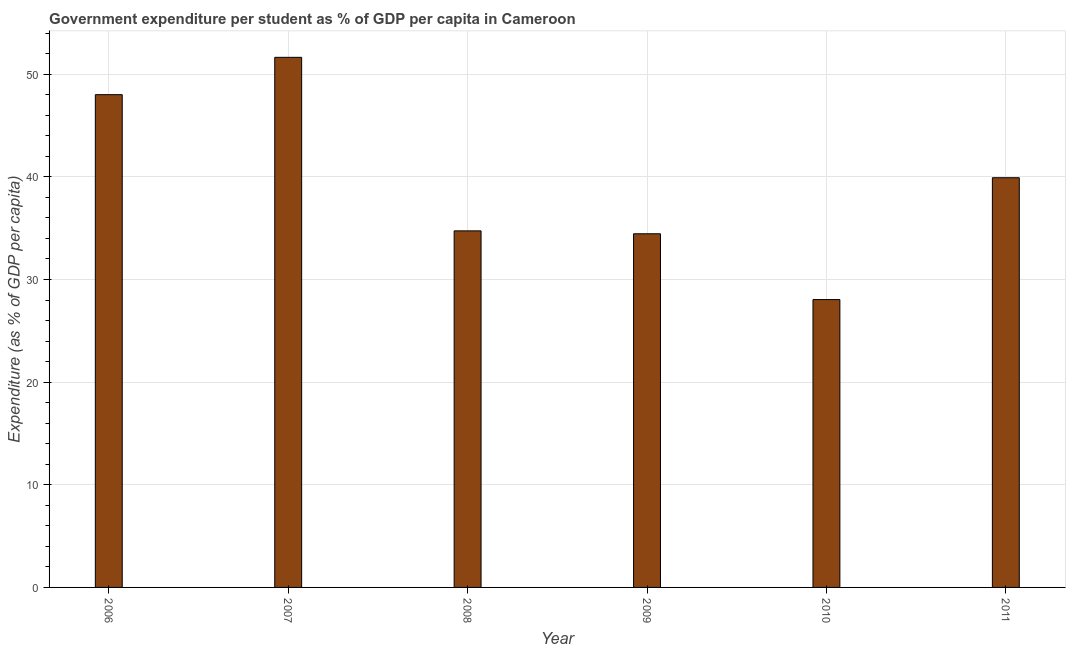Does the graph contain any zero values?
Offer a very short reply. No. What is the title of the graph?
Provide a succinct answer. Government expenditure per student as % of GDP per capita in Cameroon. What is the label or title of the X-axis?
Ensure brevity in your answer.  Year. What is the label or title of the Y-axis?
Your answer should be very brief. Expenditure (as % of GDP per capita). What is the government expenditure per student in 2006?
Ensure brevity in your answer.  48.01. Across all years, what is the maximum government expenditure per student?
Ensure brevity in your answer.  51.64. Across all years, what is the minimum government expenditure per student?
Keep it short and to the point. 28.04. In which year was the government expenditure per student maximum?
Offer a very short reply. 2007. What is the sum of the government expenditure per student?
Your response must be concise. 236.81. What is the difference between the government expenditure per student in 2006 and 2010?
Keep it short and to the point. 19.96. What is the average government expenditure per student per year?
Your answer should be very brief. 39.47. What is the median government expenditure per student?
Provide a short and direct response. 37.33. What is the ratio of the government expenditure per student in 2007 to that in 2010?
Make the answer very short. 1.84. Is the difference between the government expenditure per student in 2009 and 2011 greater than the difference between any two years?
Keep it short and to the point. No. What is the difference between the highest and the second highest government expenditure per student?
Provide a succinct answer. 3.64. What is the difference between the highest and the lowest government expenditure per student?
Make the answer very short. 23.6. How many bars are there?
Offer a very short reply. 6. Are all the bars in the graph horizontal?
Provide a short and direct response. No. How many years are there in the graph?
Offer a terse response. 6. What is the difference between two consecutive major ticks on the Y-axis?
Make the answer very short. 10. What is the Expenditure (as % of GDP per capita) in 2006?
Your response must be concise. 48.01. What is the Expenditure (as % of GDP per capita) in 2007?
Your answer should be compact. 51.64. What is the Expenditure (as % of GDP per capita) of 2008?
Your answer should be compact. 34.74. What is the Expenditure (as % of GDP per capita) of 2009?
Offer a terse response. 34.46. What is the Expenditure (as % of GDP per capita) of 2010?
Ensure brevity in your answer.  28.04. What is the Expenditure (as % of GDP per capita) in 2011?
Give a very brief answer. 39.92. What is the difference between the Expenditure (as % of GDP per capita) in 2006 and 2007?
Ensure brevity in your answer.  -3.64. What is the difference between the Expenditure (as % of GDP per capita) in 2006 and 2008?
Ensure brevity in your answer.  13.27. What is the difference between the Expenditure (as % of GDP per capita) in 2006 and 2009?
Offer a terse response. 13.55. What is the difference between the Expenditure (as % of GDP per capita) in 2006 and 2010?
Your answer should be very brief. 19.96. What is the difference between the Expenditure (as % of GDP per capita) in 2006 and 2011?
Your answer should be very brief. 8.09. What is the difference between the Expenditure (as % of GDP per capita) in 2007 and 2008?
Provide a succinct answer. 16.91. What is the difference between the Expenditure (as % of GDP per capita) in 2007 and 2009?
Make the answer very short. 17.19. What is the difference between the Expenditure (as % of GDP per capita) in 2007 and 2010?
Offer a very short reply. 23.6. What is the difference between the Expenditure (as % of GDP per capita) in 2007 and 2011?
Provide a short and direct response. 11.73. What is the difference between the Expenditure (as % of GDP per capita) in 2008 and 2009?
Provide a succinct answer. 0.28. What is the difference between the Expenditure (as % of GDP per capita) in 2008 and 2010?
Provide a succinct answer. 6.69. What is the difference between the Expenditure (as % of GDP per capita) in 2008 and 2011?
Your answer should be very brief. -5.18. What is the difference between the Expenditure (as % of GDP per capita) in 2009 and 2010?
Your answer should be compact. 6.41. What is the difference between the Expenditure (as % of GDP per capita) in 2009 and 2011?
Ensure brevity in your answer.  -5.46. What is the difference between the Expenditure (as % of GDP per capita) in 2010 and 2011?
Ensure brevity in your answer.  -11.87. What is the ratio of the Expenditure (as % of GDP per capita) in 2006 to that in 2007?
Provide a short and direct response. 0.93. What is the ratio of the Expenditure (as % of GDP per capita) in 2006 to that in 2008?
Make the answer very short. 1.38. What is the ratio of the Expenditure (as % of GDP per capita) in 2006 to that in 2009?
Give a very brief answer. 1.39. What is the ratio of the Expenditure (as % of GDP per capita) in 2006 to that in 2010?
Offer a very short reply. 1.71. What is the ratio of the Expenditure (as % of GDP per capita) in 2006 to that in 2011?
Your answer should be compact. 1.2. What is the ratio of the Expenditure (as % of GDP per capita) in 2007 to that in 2008?
Make the answer very short. 1.49. What is the ratio of the Expenditure (as % of GDP per capita) in 2007 to that in 2009?
Offer a very short reply. 1.5. What is the ratio of the Expenditure (as % of GDP per capita) in 2007 to that in 2010?
Provide a succinct answer. 1.84. What is the ratio of the Expenditure (as % of GDP per capita) in 2007 to that in 2011?
Keep it short and to the point. 1.29. What is the ratio of the Expenditure (as % of GDP per capita) in 2008 to that in 2009?
Offer a very short reply. 1.01. What is the ratio of the Expenditure (as % of GDP per capita) in 2008 to that in 2010?
Provide a short and direct response. 1.24. What is the ratio of the Expenditure (as % of GDP per capita) in 2008 to that in 2011?
Provide a succinct answer. 0.87. What is the ratio of the Expenditure (as % of GDP per capita) in 2009 to that in 2010?
Keep it short and to the point. 1.23. What is the ratio of the Expenditure (as % of GDP per capita) in 2009 to that in 2011?
Your response must be concise. 0.86. What is the ratio of the Expenditure (as % of GDP per capita) in 2010 to that in 2011?
Give a very brief answer. 0.7. 